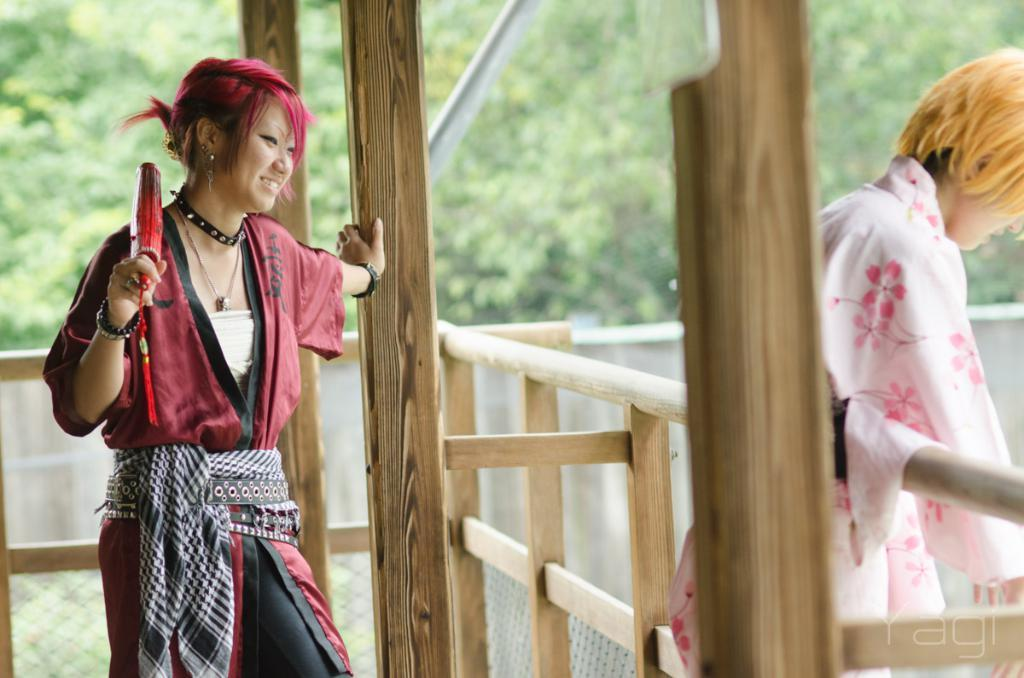How many people are in the image? There are two people in the image. What can be observed about the clothing of the people in the image? The people are wearing different color dresses. What type of structure can be seen in the image? There is a wooden fence in the image. What other objects are present in the image? There are poles in the image. What can be seen in the background of the image? There are many trees in the background of the image. What type of pot is being used to grip the match in the image? There is no pot or match present in the image. 